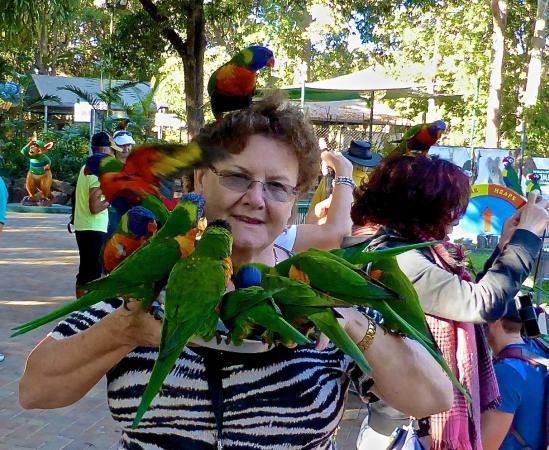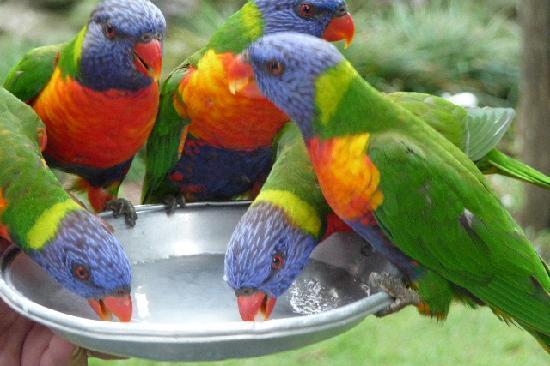The first image is the image on the left, the second image is the image on the right. Examine the images to the left and right. Is the description "Birds are perched on a person in the image on the left." accurate? Answer yes or no. Yes. The first image is the image on the left, the second image is the image on the right. Given the left and right images, does the statement "At least one image shows multiple parrots with beaks bent toward a round pan and does not show any human faces." hold true? Answer yes or no. Yes. 